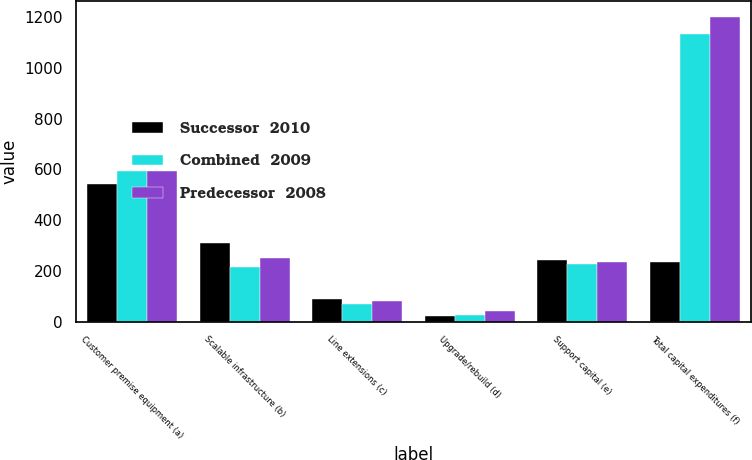Convert chart to OTSL. <chart><loc_0><loc_0><loc_500><loc_500><stacked_bar_chart><ecel><fcel>Customer premise equipment (a)<fcel>Scalable infrastructure (b)<fcel>Line extensions (c)<fcel>Upgrade/rebuild (d)<fcel>Support capital (e)<fcel>Total capital expenditures (f)<nl><fcel>Successor  2010<fcel>543<fcel>311<fcel>90<fcel>21<fcel>244<fcel>236<nl><fcel>Combined  2009<fcel>593<fcel>216<fcel>70<fcel>28<fcel>227<fcel>1134<nl><fcel>Predecessor  2008<fcel>595<fcel>251<fcel>80<fcel>40<fcel>236<fcel>1202<nl></chart> 